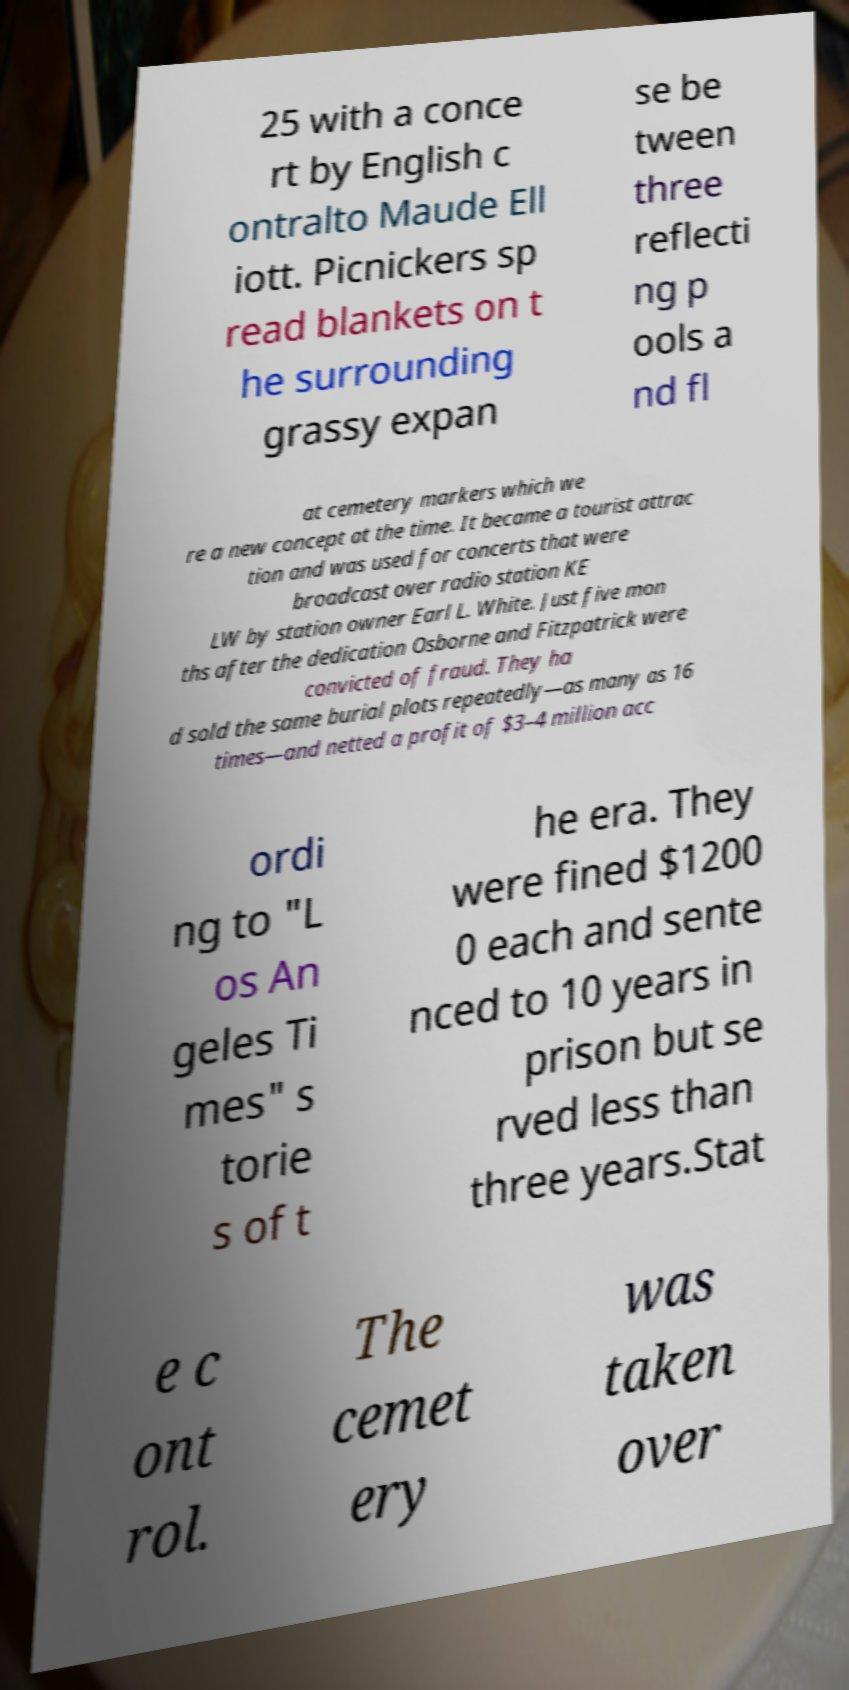Can you read and provide the text displayed in the image?This photo seems to have some interesting text. Can you extract and type it out for me? 25 with a conce rt by English c ontralto Maude Ell iott. Picnickers sp read blankets on t he surrounding grassy expan se be tween three reflecti ng p ools a nd fl at cemetery markers which we re a new concept at the time. It became a tourist attrac tion and was used for concerts that were broadcast over radio station KE LW by station owner Earl L. White. Just five mon ths after the dedication Osborne and Fitzpatrick were convicted of fraud. They ha d sold the same burial plots repeatedly—as many as 16 times—and netted a profit of $3–4 million acc ordi ng to "L os An geles Ti mes" s torie s of t he era. They were fined $1200 0 each and sente nced to 10 years in prison but se rved less than three years.Stat e c ont rol. The cemet ery was taken over 